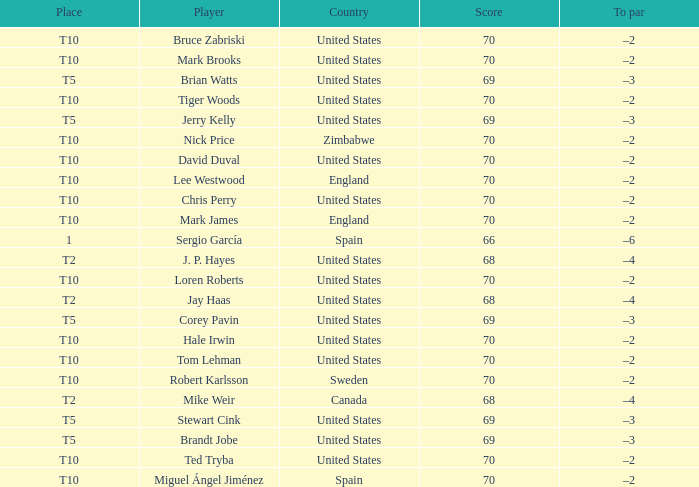I'm looking to parse the entire table for insights. Could you assist me with that? {'header': ['Place', 'Player', 'Country', 'Score', 'To par'], 'rows': [['T10', 'Bruce Zabriski', 'United States', '70', '–2'], ['T10', 'Mark Brooks', 'United States', '70', '–2'], ['T5', 'Brian Watts', 'United States', '69', '–3'], ['T10', 'Tiger Woods', 'United States', '70', '–2'], ['T5', 'Jerry Kelly', 'United States', '69', '–3'], ['T10', 'Nick Price', 'Zimbabwe', '70', '–2'], ['T10', 'David Duval', 'United States', '70', '–2'], ['T10', 'Lee Westwood', 'England', '70', '–2'], ['T10', 'Chris Perry', 'United States', '70', '–2'], ['T10', 'Mark James', 'England', '70', '–2'], ['1', 'Sergio García', 'Spain', '66', '–6'], ['T2', 'J. P. Hayes', 'United States', '68', '–4'], ['T10', 'Loren Roberts', 'United States', '70', '–2'], ['T2', 'Jay Haas', 'United States', '68', '–4'], ['T5', 'Corey Pavin', 'United States', '69', '–3'], ['T10', 'Hale Irwin', 'United States', '70', '–2'], ['T10', 'Tom Lehman', 'United States', '70', '–2'], ['T10', 'Robert Karlsson', 'Sweden', '70', '–2'], ['T2', 'Mike Weir', 'Canada', '68', '–4'], ['T5', 'Stewart Cink', 'United States', '69', '–3'], ['T5', 'Brandt Jobe', 'United States', '69', '–3'], ['T10', 'Ted Tryba', 'United States', '70', '–2'], ['T10', 'Miguel Ángel Jiménez', 'Spain', '70', '–2']]} What was the highest score of t5 place finisher brandt jobe? 69.0. 